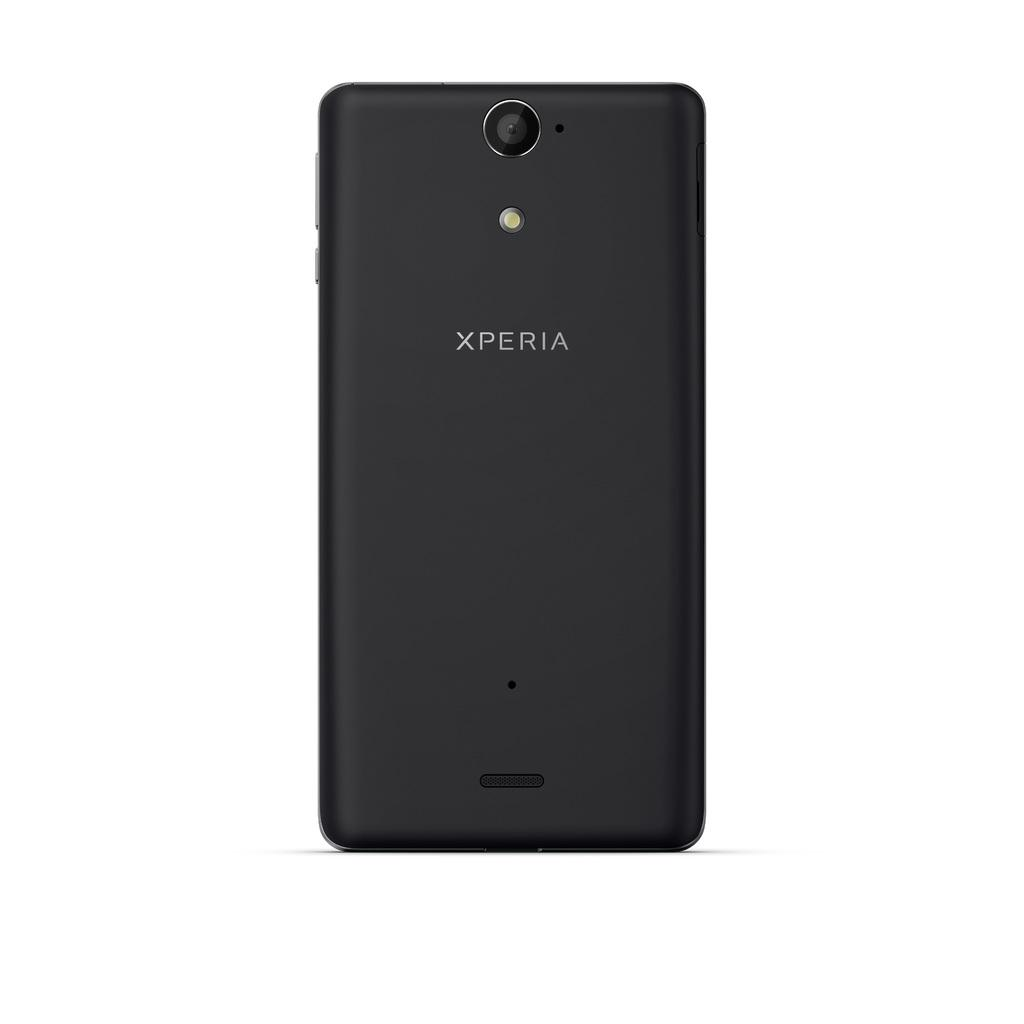<image>
Share a concise interpretation of the image provided. The rear of an Xperia phone is black and has the camera lens at the top. 